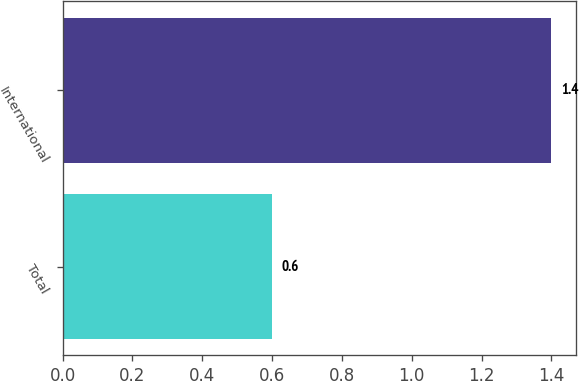Convert chart. <chart><loc_0><loc_0><loc_500><loc_500><bar_chart><fcel>Total<fcel>International<nl><fcel>0.6<fcel>1.4<nl></chart> 